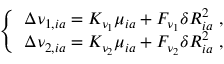<formula> <loc_0><loc_0><loc_500><loc_500>\begin{array} { r } { \left \{ \begin{array} { l l } { \Delta \nu _ { 1 , i a } = K _ { \nu _ { 1 } } \mu _ { i a } + F _ { \nu _ { 1 } } \delta R _ { i a } ^ { 2 } \ , } \\ { \Delta \nu _ { 2 , i a } = K _ { \nu _ { 2 } } \mu _ { i a } + F _ { \nu _ { 2 } } \delta R _ { i a } ^ { 2 } \ , } \end{array} } \end{array}</formula> 